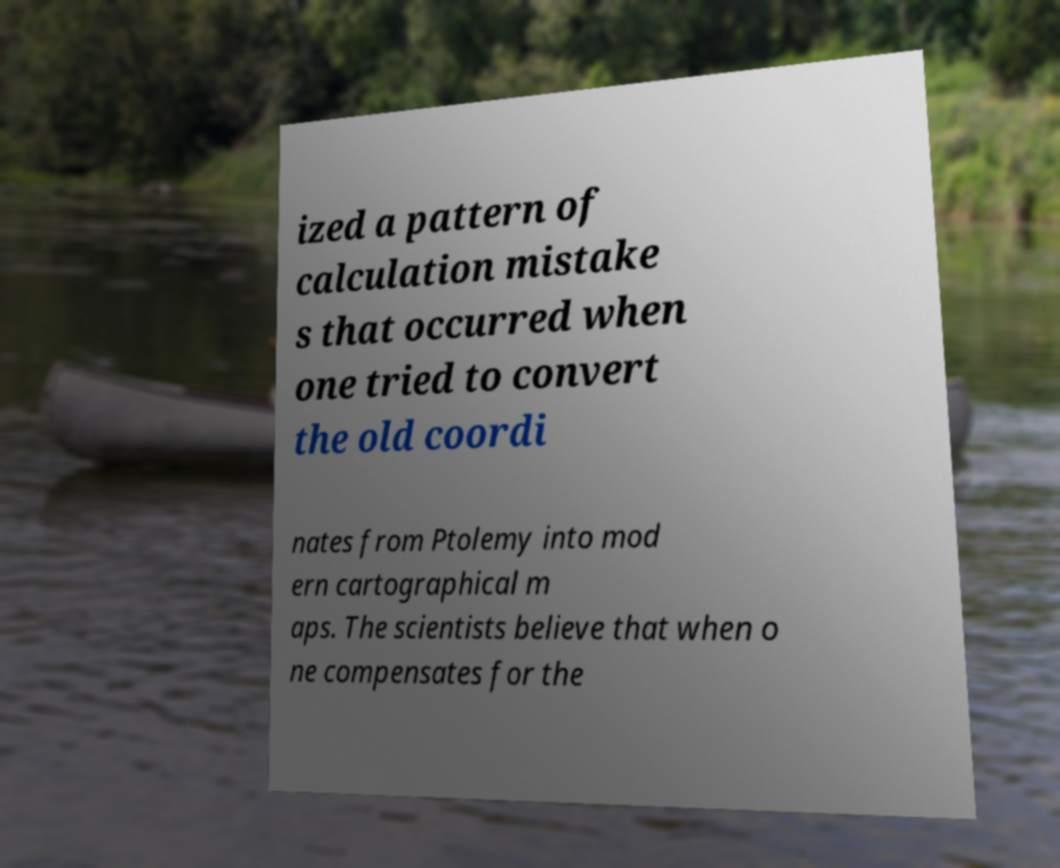Could you extract and type out the text from this image? ized a pattern of calculation mistake s that occurred when one tried to convert the old coordi nates from Ptolemy into mod ern cartographical m aps. The scientists believe that when o ne compensates for the 